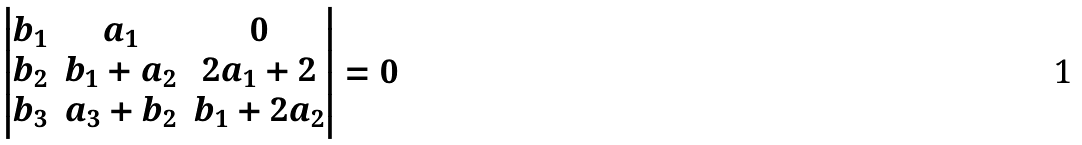Convert formula to latex. <formula><loc_0><loc_0><loc_500><loc_500>\left | \begin{matrix} b _ { 1 } & a _ { 1 } & 0 \\ b _ { 2 } & b _ { 1 } + a _ { 2 } & 2 a _ { 1 } + 2 \\ b _ { 3 } & a _ { 3 } + b _ { 2 } & b _ { 1 } + 2 a _ { 2 } \end{matrix} \right | = 0</formula> 